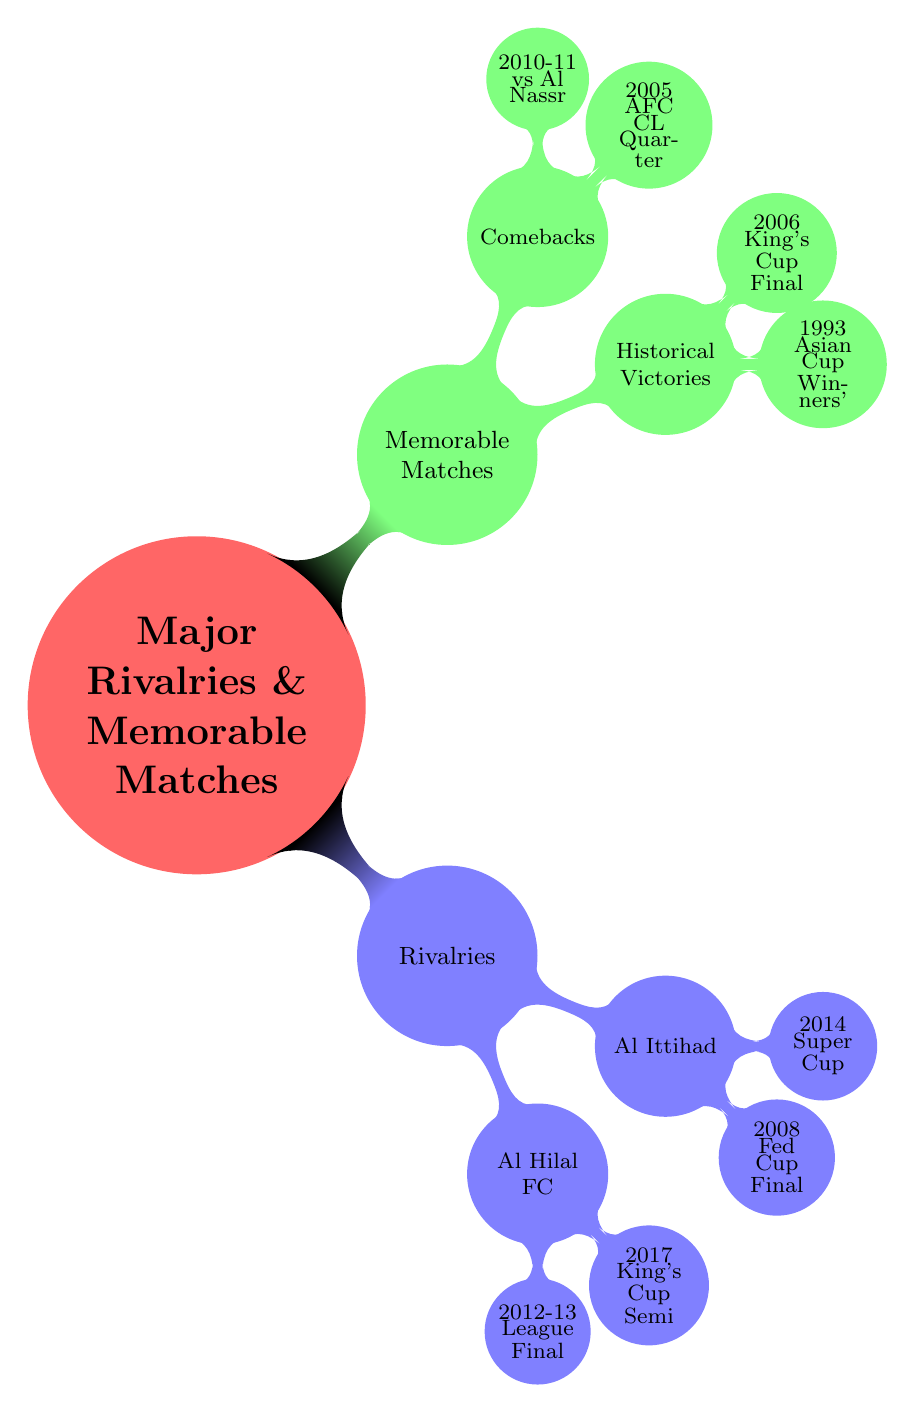What is the primary focus of the mind map? The central node indicates that the mind map focuses on "Major Rivalries & Memorable Matches". This is the main topic that encompasses the subcategories below it.
Answer: Major Rivalries & Memorable Matches How many main categories are present in the diagram? There are two main categories: "Rivalries" and "Memorable Matches". These are the primary divisions under the main topic.
Answer: 2 Who is Al Shabab's rival that they have a historical context with since the 1970s? According to the diagram, Al Shabab has a long-standing rivalry with Al Hilal FC that dates back to the 1970s. This information is explicitly stated under the "Al Hilal FC" node.
Answer: Al Hilal FC What was the result of the 2012–2013 Saudi Pro League Final between Al Shabab and Al Hilal? The diagram specifies that in the final, Al Shabab won against Al Hilal with a score of 3–2. This information is found directly under the key matches listed for Al Hilal FC.
Answer: Al Shabab 3–2 Al Hilal Which memorable match resulted in a historical victory against Oro from Japan? The diagram shows that the match against Oro in the 1993 Asian Cup Winners' Cup Final resulted in a victory for Al Shabab with a score of 2–0. This is found under the "Historical Victories" category.
Answer: 1993 Asian Cup Winners' Cup Final Which rival had Al Shabab's 2008 Saudi Federation Cup Final match? The mind map indicates that the 2008 Saudi Federation Cup Final was contested against Al Ittihad, specified under the "Al Ittihad" node.
Answer: Al Ittihad What is the result of the 2017 King's Cup semi-final match against Al Hilal? The diagram notes that the 2017 King's Cup Semi-final ended in a 1–1 draw, and Al Shabab subsequently won in penalties. This information indicates the match outcome clearly.
Answer: 1–1 (Al Shabab won in penalties) How many notable matches fall under the "Comebacks" category? The diagram shows that two notable matches are categorized under "Comebacks". These matches highlight Al Shabab's comeback performances and are listed separately from other match types.
Answer: 2 In which match did Al Shabab achieve a comeback in the 2005 AFC Champions League Quarter-final? According to the diagram, Al Shabab faced Seongnam Ilhwa Chunma in the 2005 AFC Champions League Quarter-final, where they had a significant comeback result of 5–3 on aggregate. This specific matchup is clearly noted under the "Comebacks" section.
Answer: 2005 AFC Champions League Quarter-final 